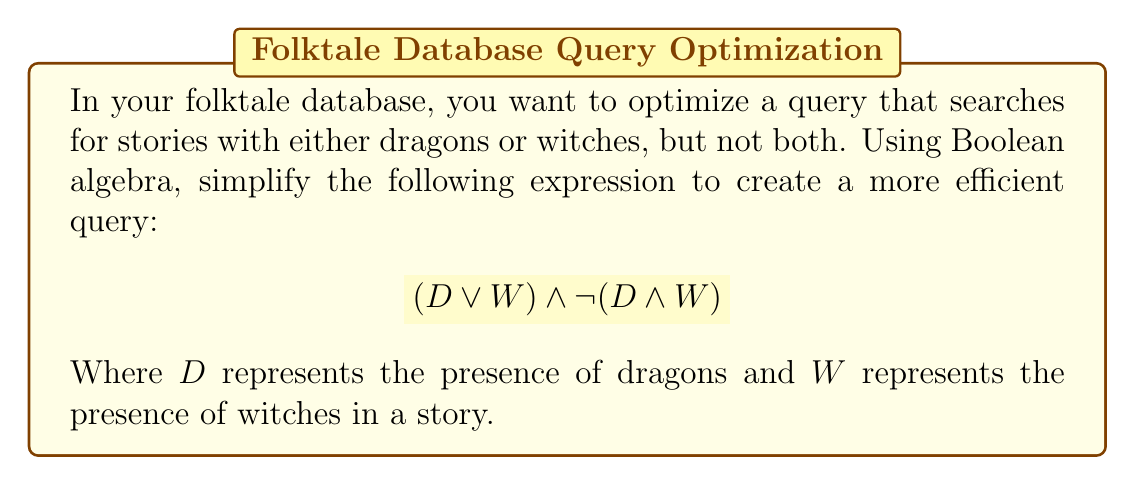Solve this math problem. To simplify this Boolean expression, we can follow these steps:

1. Start with the given expression:
   $$(D \lor W) \land \lnot(D \land W)$$

2. Apply De Morgan's law to the second part:
   $$(D \lor W) \land (\lnot D \lor \lnot W)$$

3. Use the distributive property to expand the expression:
   $$(D \land \lnot D) \lor (D \land \lnot W) \lor (W \land \lnot D) \lor (W \land \lnot W)$$

4. Simplify using the following rules:
   - $X \land \lnot X = 0$ (false)
   - $X \land \lnot Y = X - Y$ (set difference)

   This gives us:
   $$0 \lor (D - W) \lor (W - D) \lor 0$$

5. Simplify further:
   $$(D - W) \lor (W - D)$$

This simplified expression represents stories that have dragons but not witches, or witches but not dragons, which is equivalent to the original query but more efficient for database operations.
Answer: $(D - W) \lor (W - D)$ 